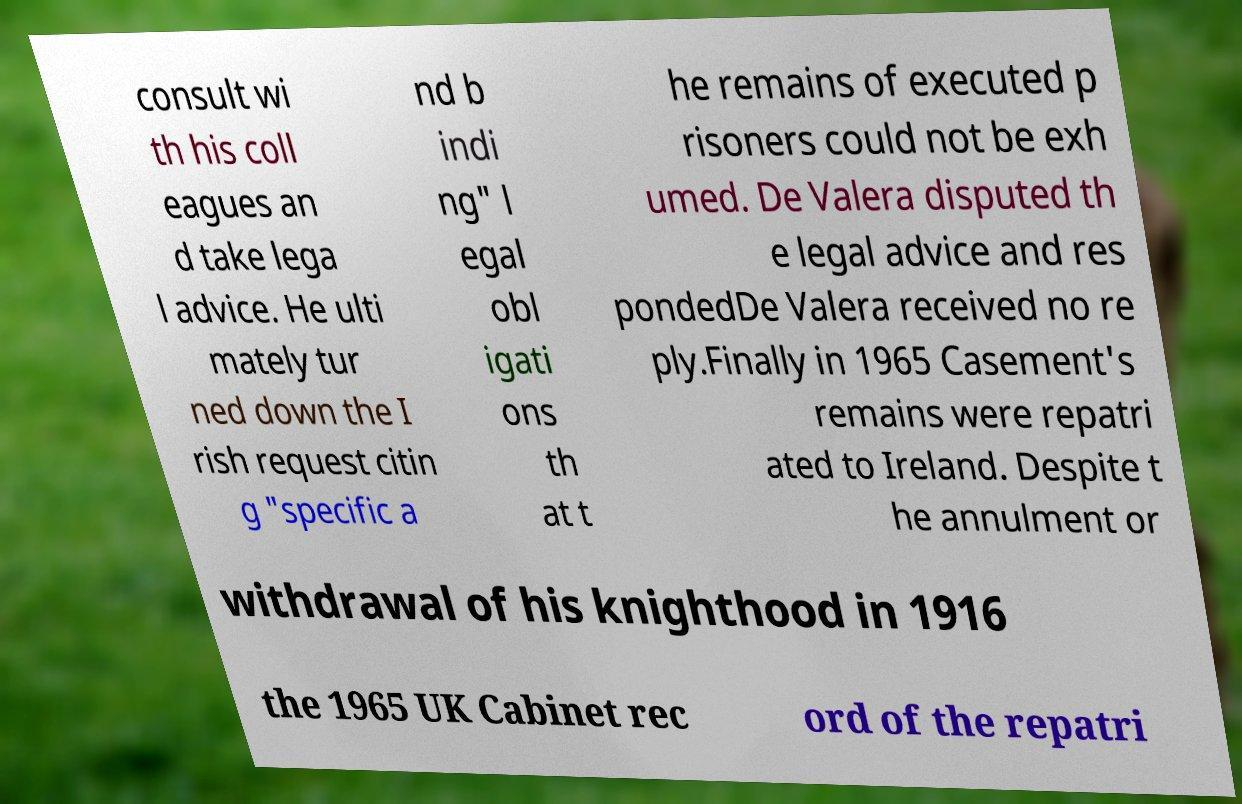I need the written content from this picture converted into text. Can you do that? consult wi th his coll eagues an d take lega l advice. He ulti mately tur ned down the I rish request citin g "specific a nd b indi ng" l egal obl igati ons th at t he remains of executed p risoners could not be exh umed. De Valera disputed th e legal advice and res pondedDe Valera received no re ply.Finally in 1965 Casement's remains were repatri ated to Ireland. Despite t he annulment or withdrawal of his knighthood in 1916 the 1965 UK Cabinet rec ord of the repatri 